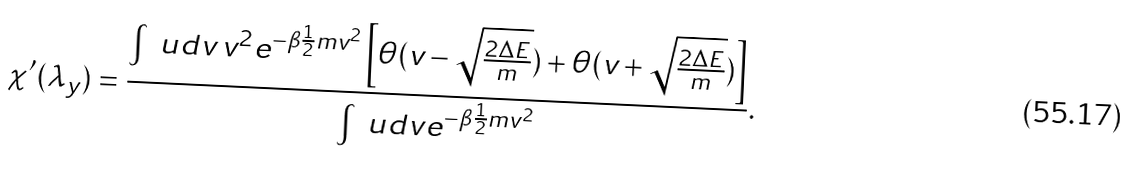<formula> <loc_0><loc_0><loc_500><loc_500>\chi ^ { \prime } ( \lambda _ { y } ) & = \frac { \int \ u d v \, v ^ { 2 } e ^ { - \beta \frac { 1 } { 2 } m v ^ { 2 } } \left [ \theta ( v - \sqrt { \frac { 2 \Delta E } { m } } ) + \theta ( v + \sqrt { \frac { 2 \Delta E } { m } } ) \right ] } { \int \ u d v e ^ { - \beta \frac { 1 } { 2 } m v ^ { 2 } } } .</formula> 